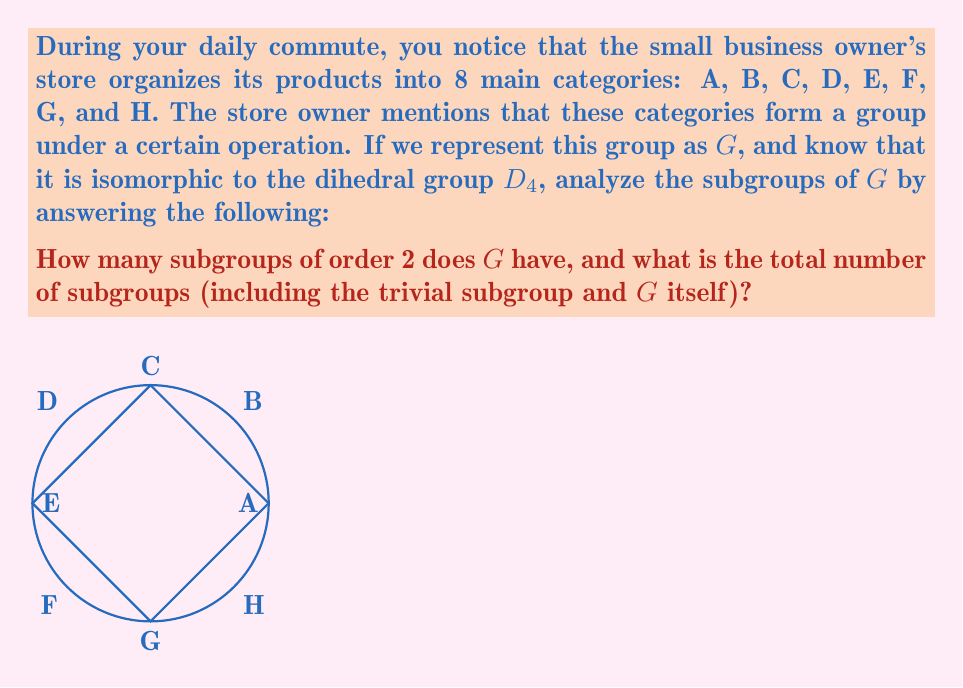What is the answer to this math problem? Let's approach this step-by-step:

1) First, recall that $D_4$ is the dihedral group of order 8, representing the symmetries of a square. Since $G$ is isomorphic to $D_4$, it will have the same subgroup structure.

2) The subgroups of $D_4$ (and thus $G$) are:
   - The trivial subgroup $\{e\}$ of order 1
   - The full group $G$ of order 8
   - One cyclic subgroup of order 4 (rotations)
   - Two cyclic subgroups of order 2 (180° rotation)
   - Three non-cyclic subgroups of order 2 (reflections)

3) To find the number of subgroups of order 2:
   - Cyclic subgroups of order 2: 2
   - Non-cyclic subgroups of order 2: 3
   - Total subgroups of order 2: 2 + 3 = 5

4) To find the total number of subgroups:
   - Order 1: 1 (trivial subgroup)
   - Order 2: 5 (as calculated above)
   - Order 4: 1 (cyclic subgroup)
   - Order 8: 1 (the full group $G$)
   - Total: 1 + 5 + 1 + 1 = 8

Therefore, $G$ has 5 subgroups of order 2 and a total of 8 subgroups.
Answer: 5 subgroups of order 2; 8 total subgroups 